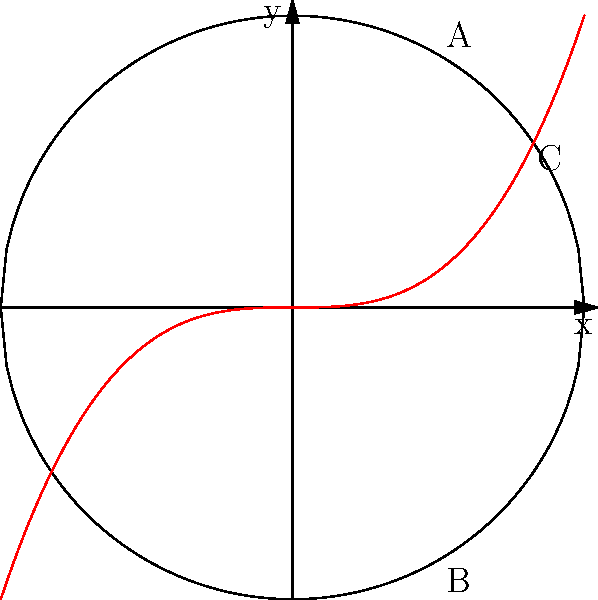In the context of abstract art styles representing topological spaces, consider the diagram where the black curves represent a circular canvas and the red curve represents a unique artistic style. Which topological space does this artistic style most likely represent, and how might this classification impact a copyright dispute? To analyze this problem, let's follow these steps:

1. Observe the diagram: The black curves form a circle, while the red curve intersects the circle at three points.

2. Topological interpretation:
   - The circle (black curves) represents a simple closed curve, topologically equivalent to $S^1$ (1-sphere).
   - The red curve represents an artistic style that creates three distinct regions within the circular canvas.

3. Topological classification:
   - The red curve divides the circular space into three connected components.
   - This division is topologically equivalent to a "pair of pants" decomposition, which is a fundamental building block in surface topology.

4. Mathematical representation:
   - The resulting space can be described as $S^1 \setminus \{p_1, p_2, p_3\}$, where $S^1$ is the circle and $p_1, p_2, p_3$ are the three intersection points.

5. Artistic interpretation:
   - This style creates a tripartite division of the canvas, possibly representing a unique approach to composition or color theory.

6. Copyright implications:
   - The topological structure of this artistic style is relatively simple but distinctive.
   - In a copyright dispute, one could argue that this particular division of space is a key characteristic of the artist's style.
   - However, the simplicity of the topological structure might make it challenging to claim exclusive rights, as it could be considered a basic compositional technique.

7. Legal consideration:
   - Copyright protection typically covers the expression of ideas, not the ideas themselves.
   - The artist would need to demonstrate that their specific implementation of this topological structure is unique and creative enough to warrant copyright protection.
Answer: Topologically equivalent to $S^1 \setminus \{p_1, p_2, p_3\}$ (circle minus three points); may impact copyright by demonstrating a distinctive but potentially basic compositional technique. 